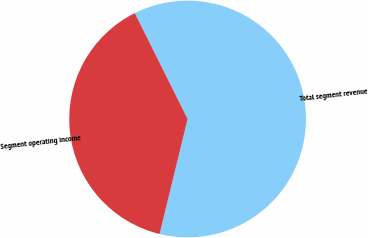<chart> <loc_0><loc_0><loc_500><loc_500><pie_chart><fcel>Total segment revenue<fcel>Segment operating income<nl><fcel>61.16%<fcel>38.84%<nl></chart> 